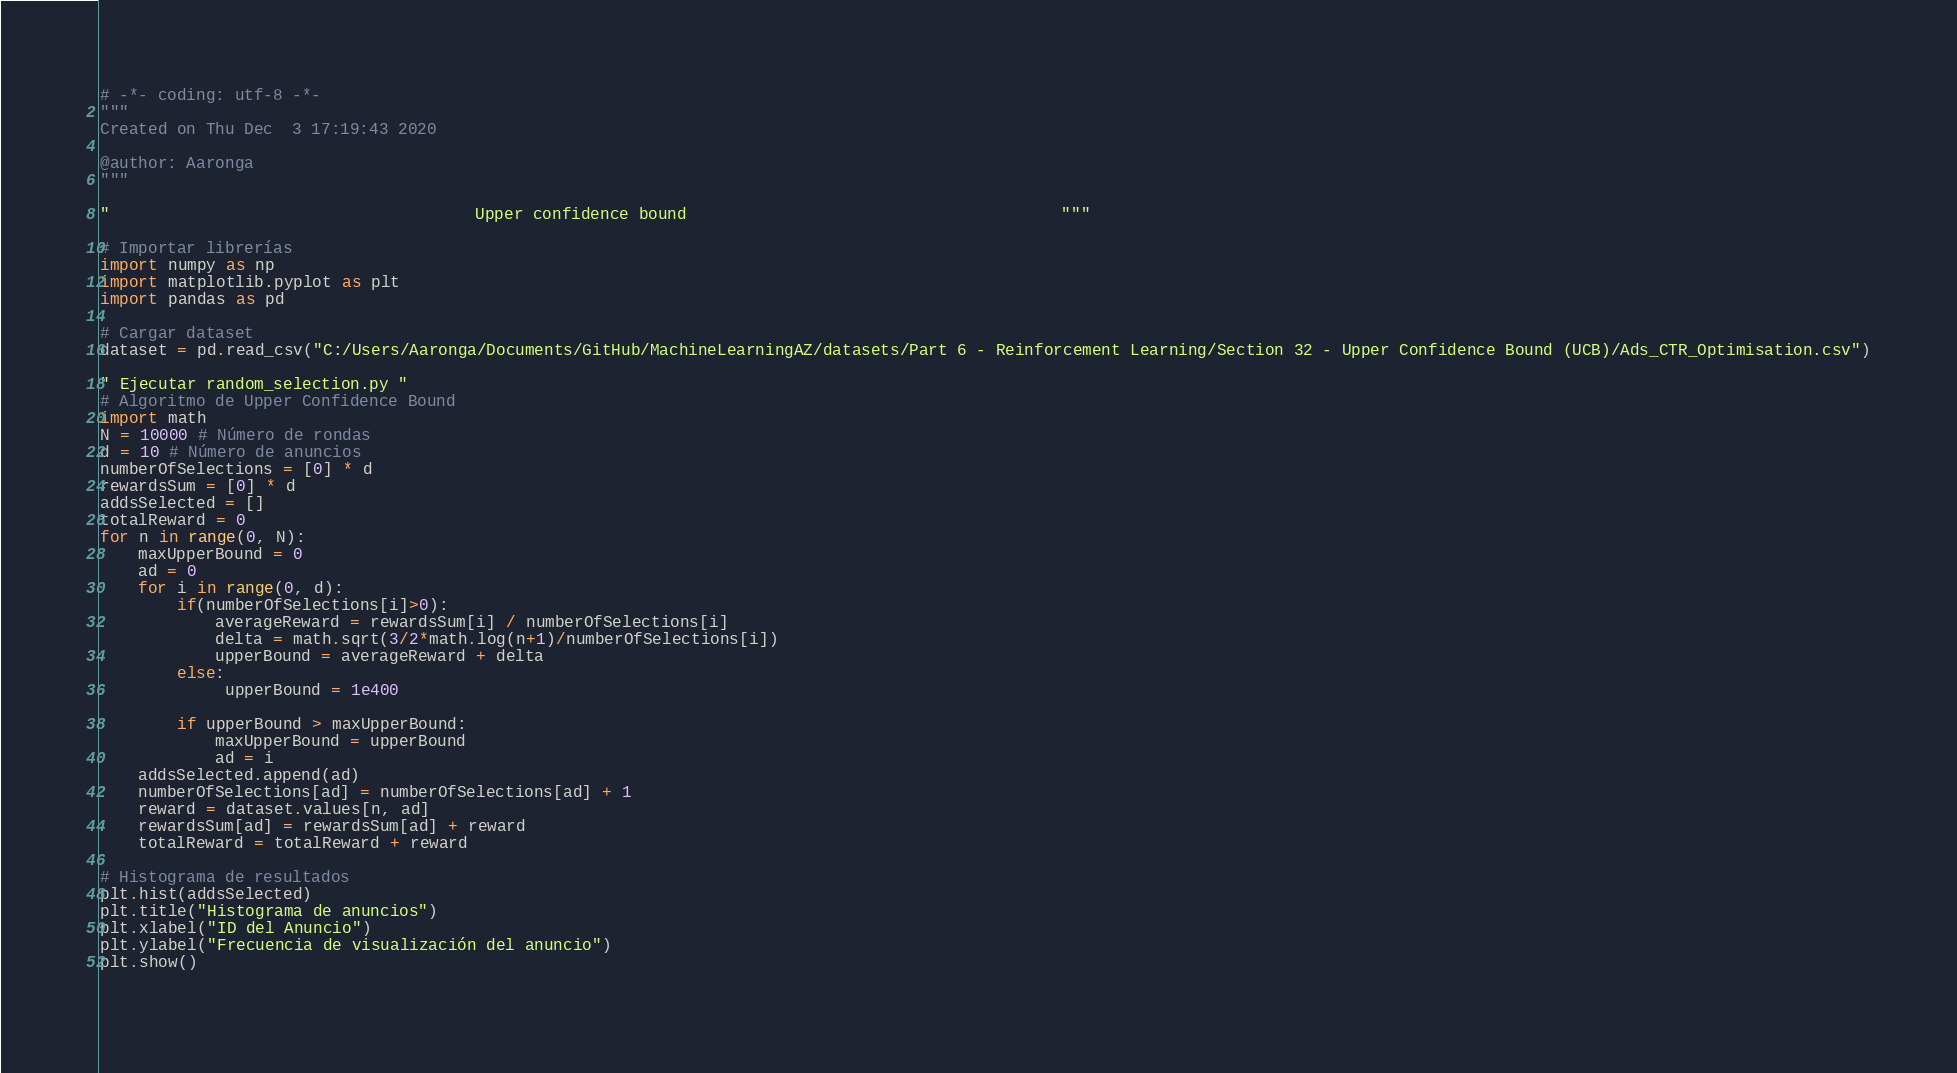<code> <loc_0><loc_0><loc_500><loc_500><_Python_># -*- coding: utf-8 -*-
"""
Created on Thu Dec  3 17:19:43 2020

@author: Aaronga
"""

"                                      Upper confidence bound                                       """

# Importar librerías 
import numpy as np
import matplotlib.pyplot as plt
import pandas as pd

# Cargar dataset
dataset = pd.read_csv("C:/Users/Aaronga/Documents/GitHub/MachineLearningAZ/datasets/Part 6 - Reinforcement Learning/Section 32 - Upper Confidence Bound (UCB)/Ads_CTR_Optimisation.csv")

" Ejecutar random_selection.py "
# Algoritmo de Upper Confidence Bound
import math
N = 10000 # Número de rondas 
d = 10 # Número de anuncios 
numberOfSelections = [0] * d
rewardsSum = [0] * d
addsSelected = []
totalReward = 0
for n in range(0, N):
    maxUpperBound = 0
    ad = 0
    for i in range(0, d):
        if(numberOfSelections[i]>0):
            averageReward = rewardsSum[i] / numberOfSelections[i]
            delta = math.sqrt(3/2*math.log(n+1)/numberOfSelections[i])
            upperBound = averageReward + delta
        else:
             upperBound = 1e400
            
        if upperBound > maxUpperBound:
            maxUpperBound = upperBound
            ad = i
    addsSelected.append(ad)
    numberOfSelections[ad] = numberOfSelections[ad] + 1
    reward = dataset.values[n, ad]
    rewardsSum[ad] = rewardsSum[ad] + reward
    totalReward = totalReward + reward
    
# Histograma de resultados
plt.hist(addsSelected)
plt.title("Histograma de anuncios")
plt.xlabel("ID del Anuncio")
plt.ylabel("Frecuencia de visualización del anuncio")
plt.show()
    </code> 